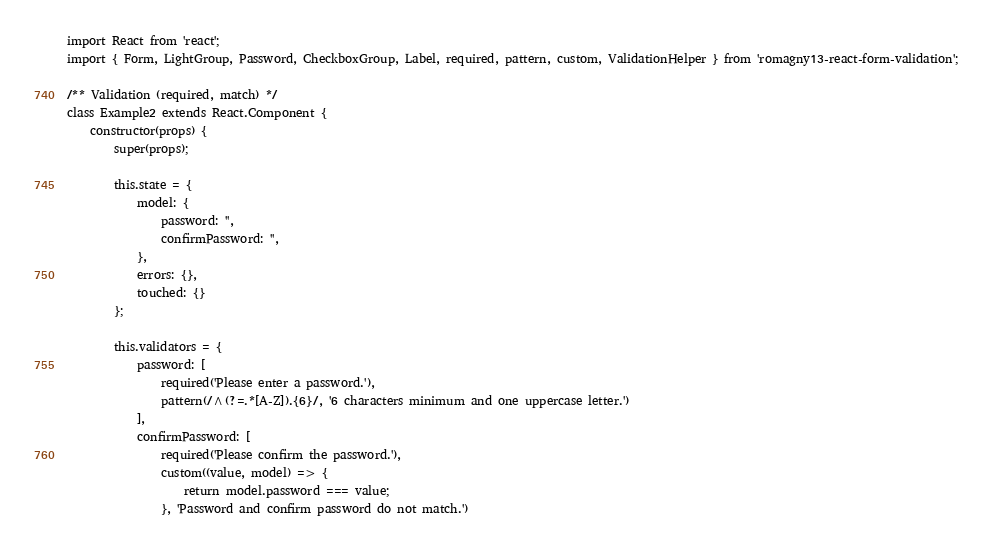<code> <loc_0><loc_0><loc_500><loc_500><_JavaScript_>import React from 'react';
import { Form, LightGroup, Password, CheckboxGroup, Label, required, pattern, custom, ValidationHelper } from 'romagny13-react-form-validation';

/** Validation (required, match) */
class Example2 extends React.Component {
    constructor(props) {
        super(props);

        this.state = {
            model: {
                password: '',
                confirmPassword: '',
            },
            errors: {},
            touched: {}
        };

        this.validators = {
            password: [
                required('Please enter a password.'),
                pattern(/^(?=.*[A-Z]).{6}/, '6 characters minimum and one uppercase letter.')
            ],
            confirmPassword: [
                required('Please confirm the password.'),
                custom((value, model) => {
                    return model.password === value;
                }, 'Password and confirm password do not match.')</code> 